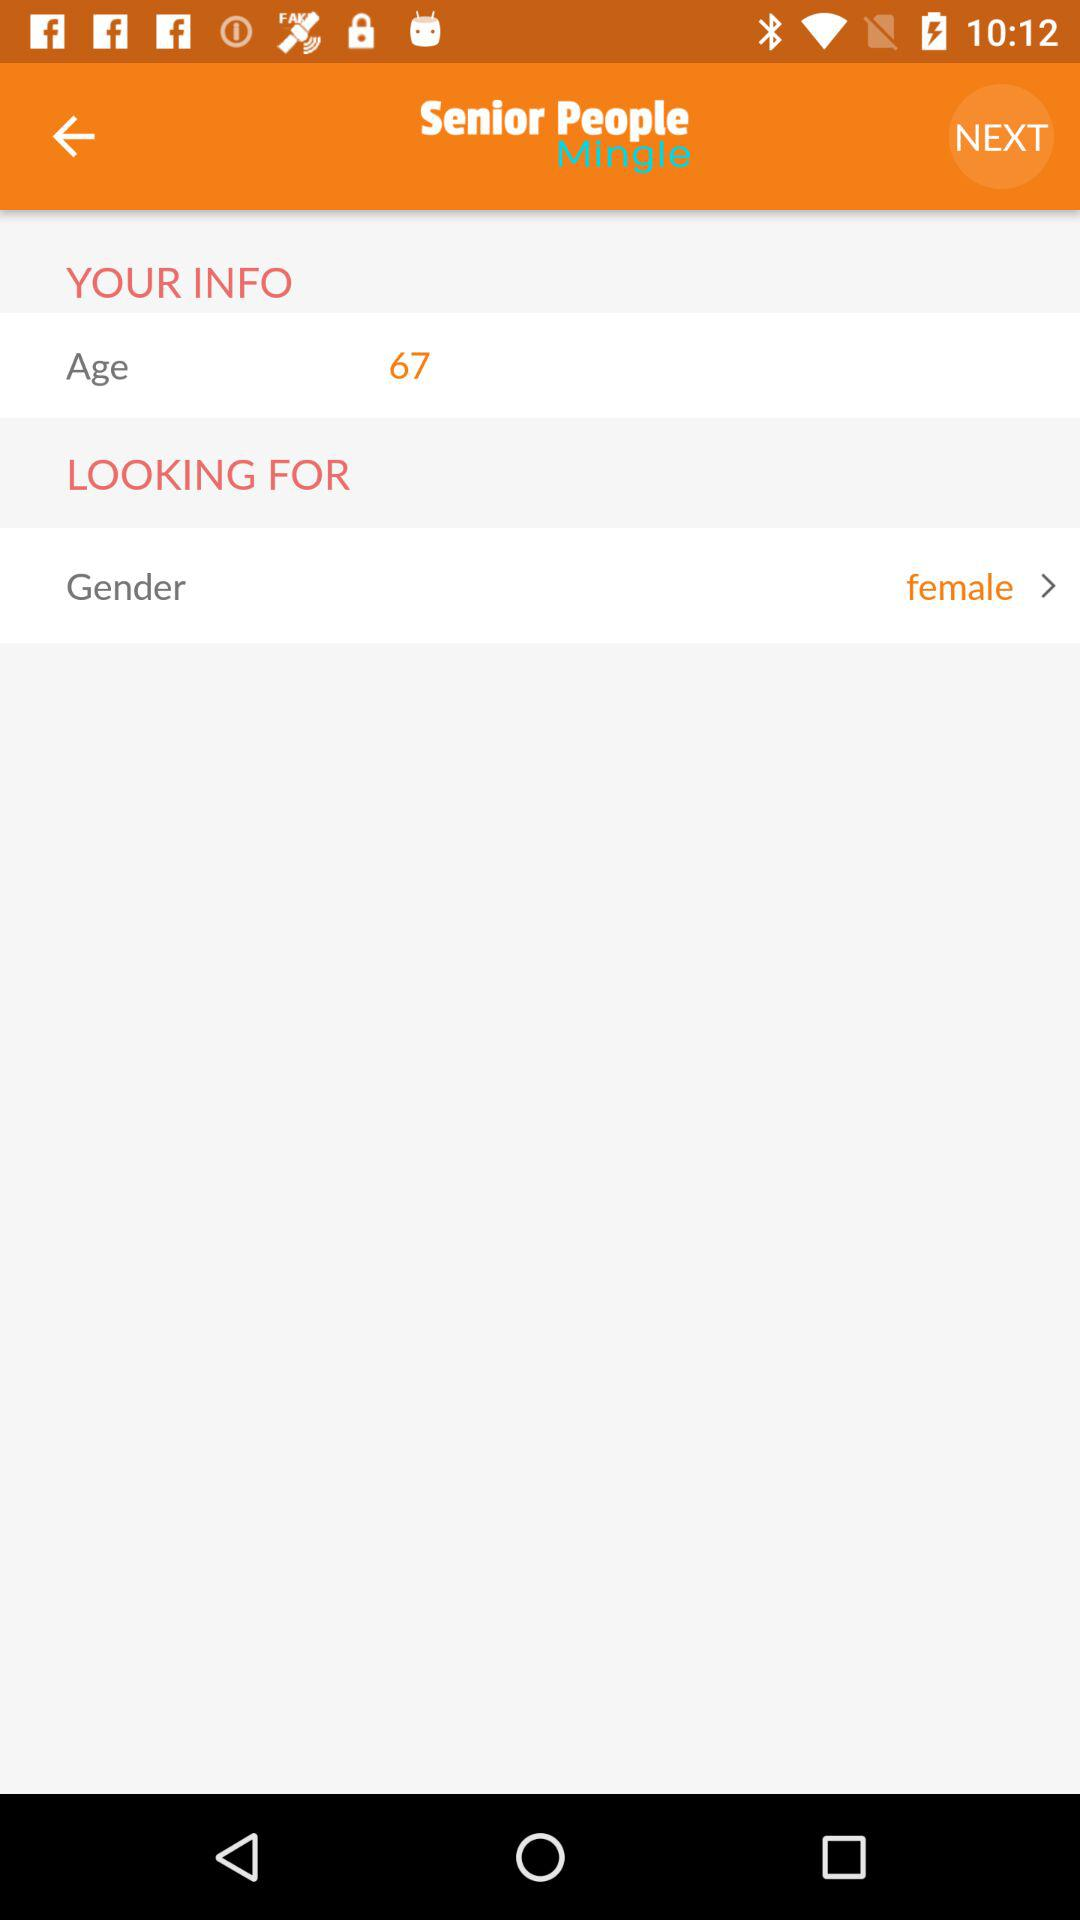What is the age? The age is 67 years. 